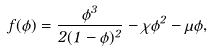Convert formula to latex. <formula><loc_0><loc_0><loc_500><loc_500>f ( \phi ) = \frac { \phi ^ { 3 } } { 2 ( 1 - \phi ) ^ { 2 } } - \chi \phi ^ { 2 } - \mu \phi ,</formula> 